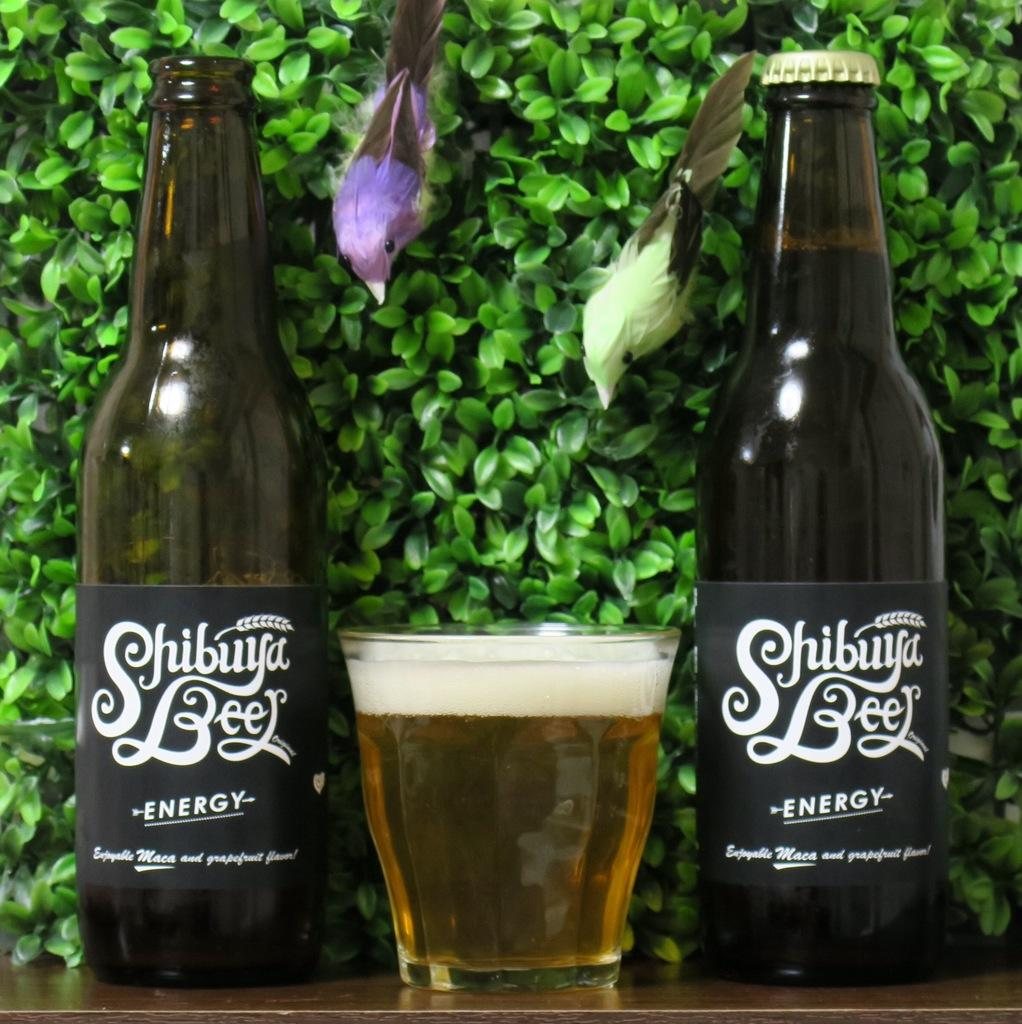How many bottles can be seen in the image? There are two bottles in the image. What other object is present in the image? There is a glass in the image. What type of animals are in the image? There are two birds in the image. What type of vegetation is present in the image? There are leafs in the image. Can you see any cheese being eaten by the birds in the image? There is no cheese present in the image, and the birds are not shown eating anything. 